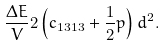Convert formula to latex. <formula><loc_0><loc_0><loc_500><loc_500>\frac { \Delta E } { V } 2 \left ( c _ { 1 3 1 3 } + \frac { 1 } { 2 } p \right ) d ^ { 2 } .</formula> 